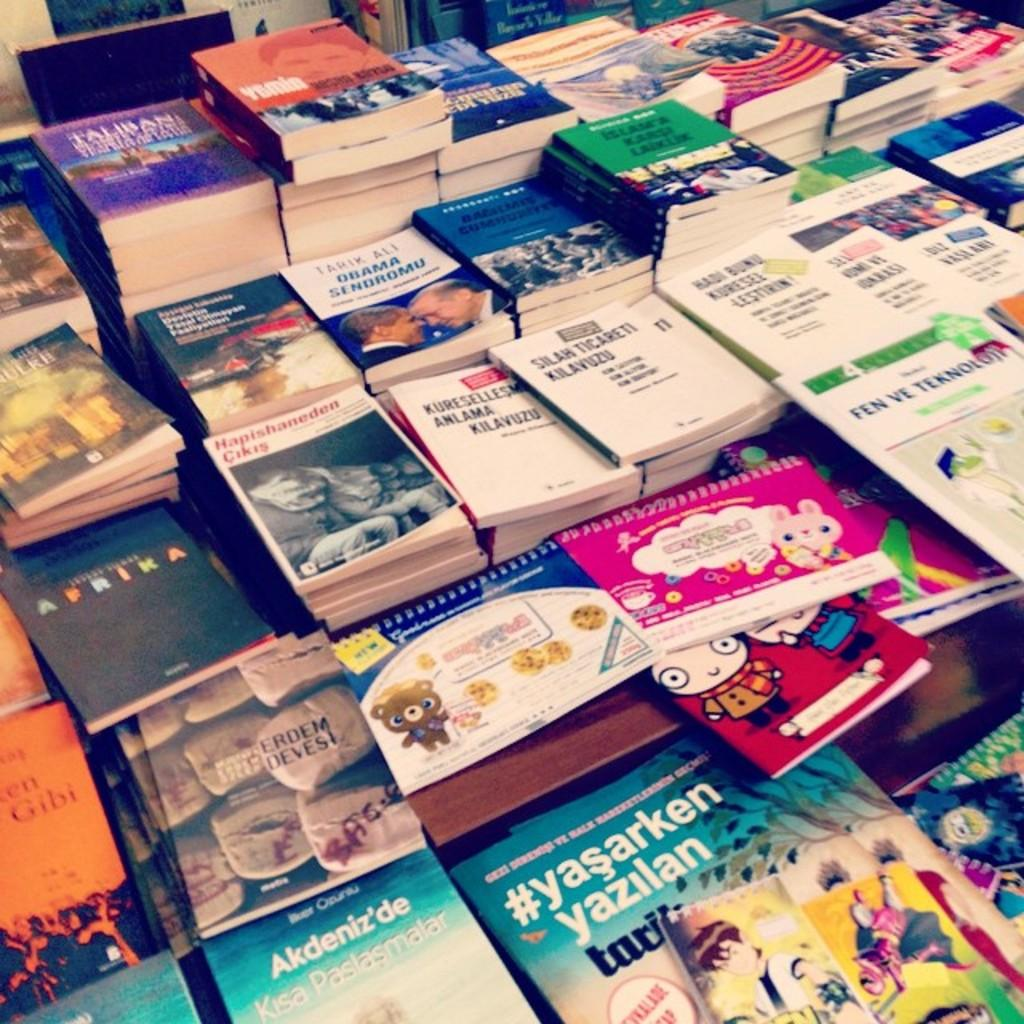Provide a one-sentence caption for the provided image. Many books, incuding #yasarken yazilan, stacked on a table. 